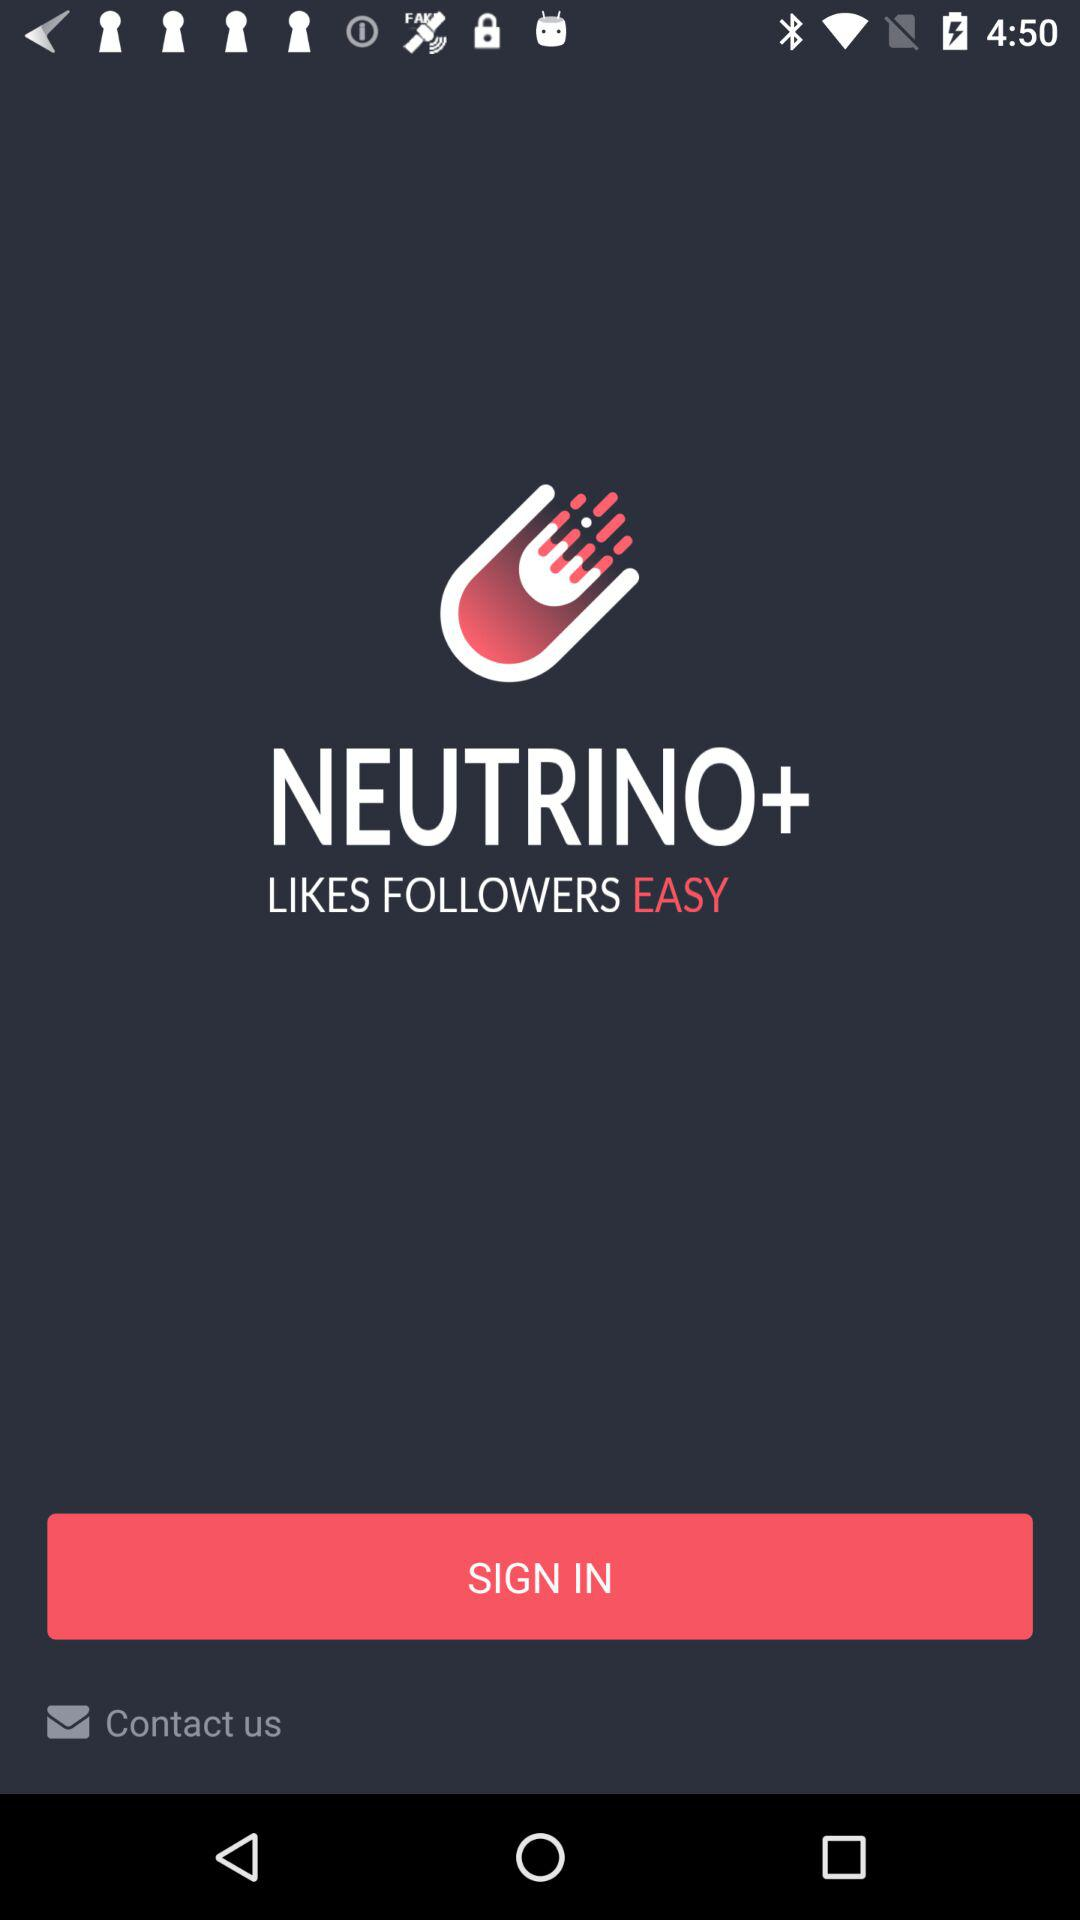What is the application name? The application name is "NEUTRINO+". 